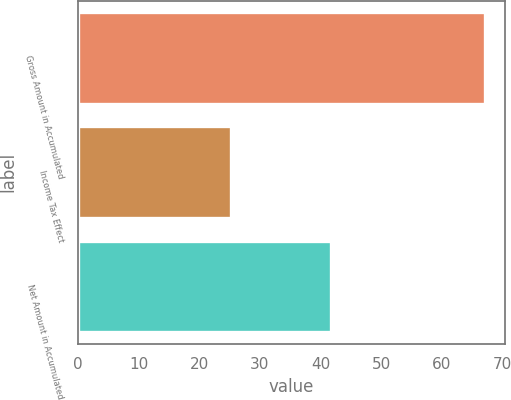Convert chart to OTSL. <chart><loc_0><loc_0><loc_500><loc_500><bar_chart><fcel>Gross Amount in Accumulated<fcel>Income Tax Effect<fcel>Net Amount in Accumulated<nl><fcel>67.1<fcel>25.3<fcel>41.8<nl></chart> 